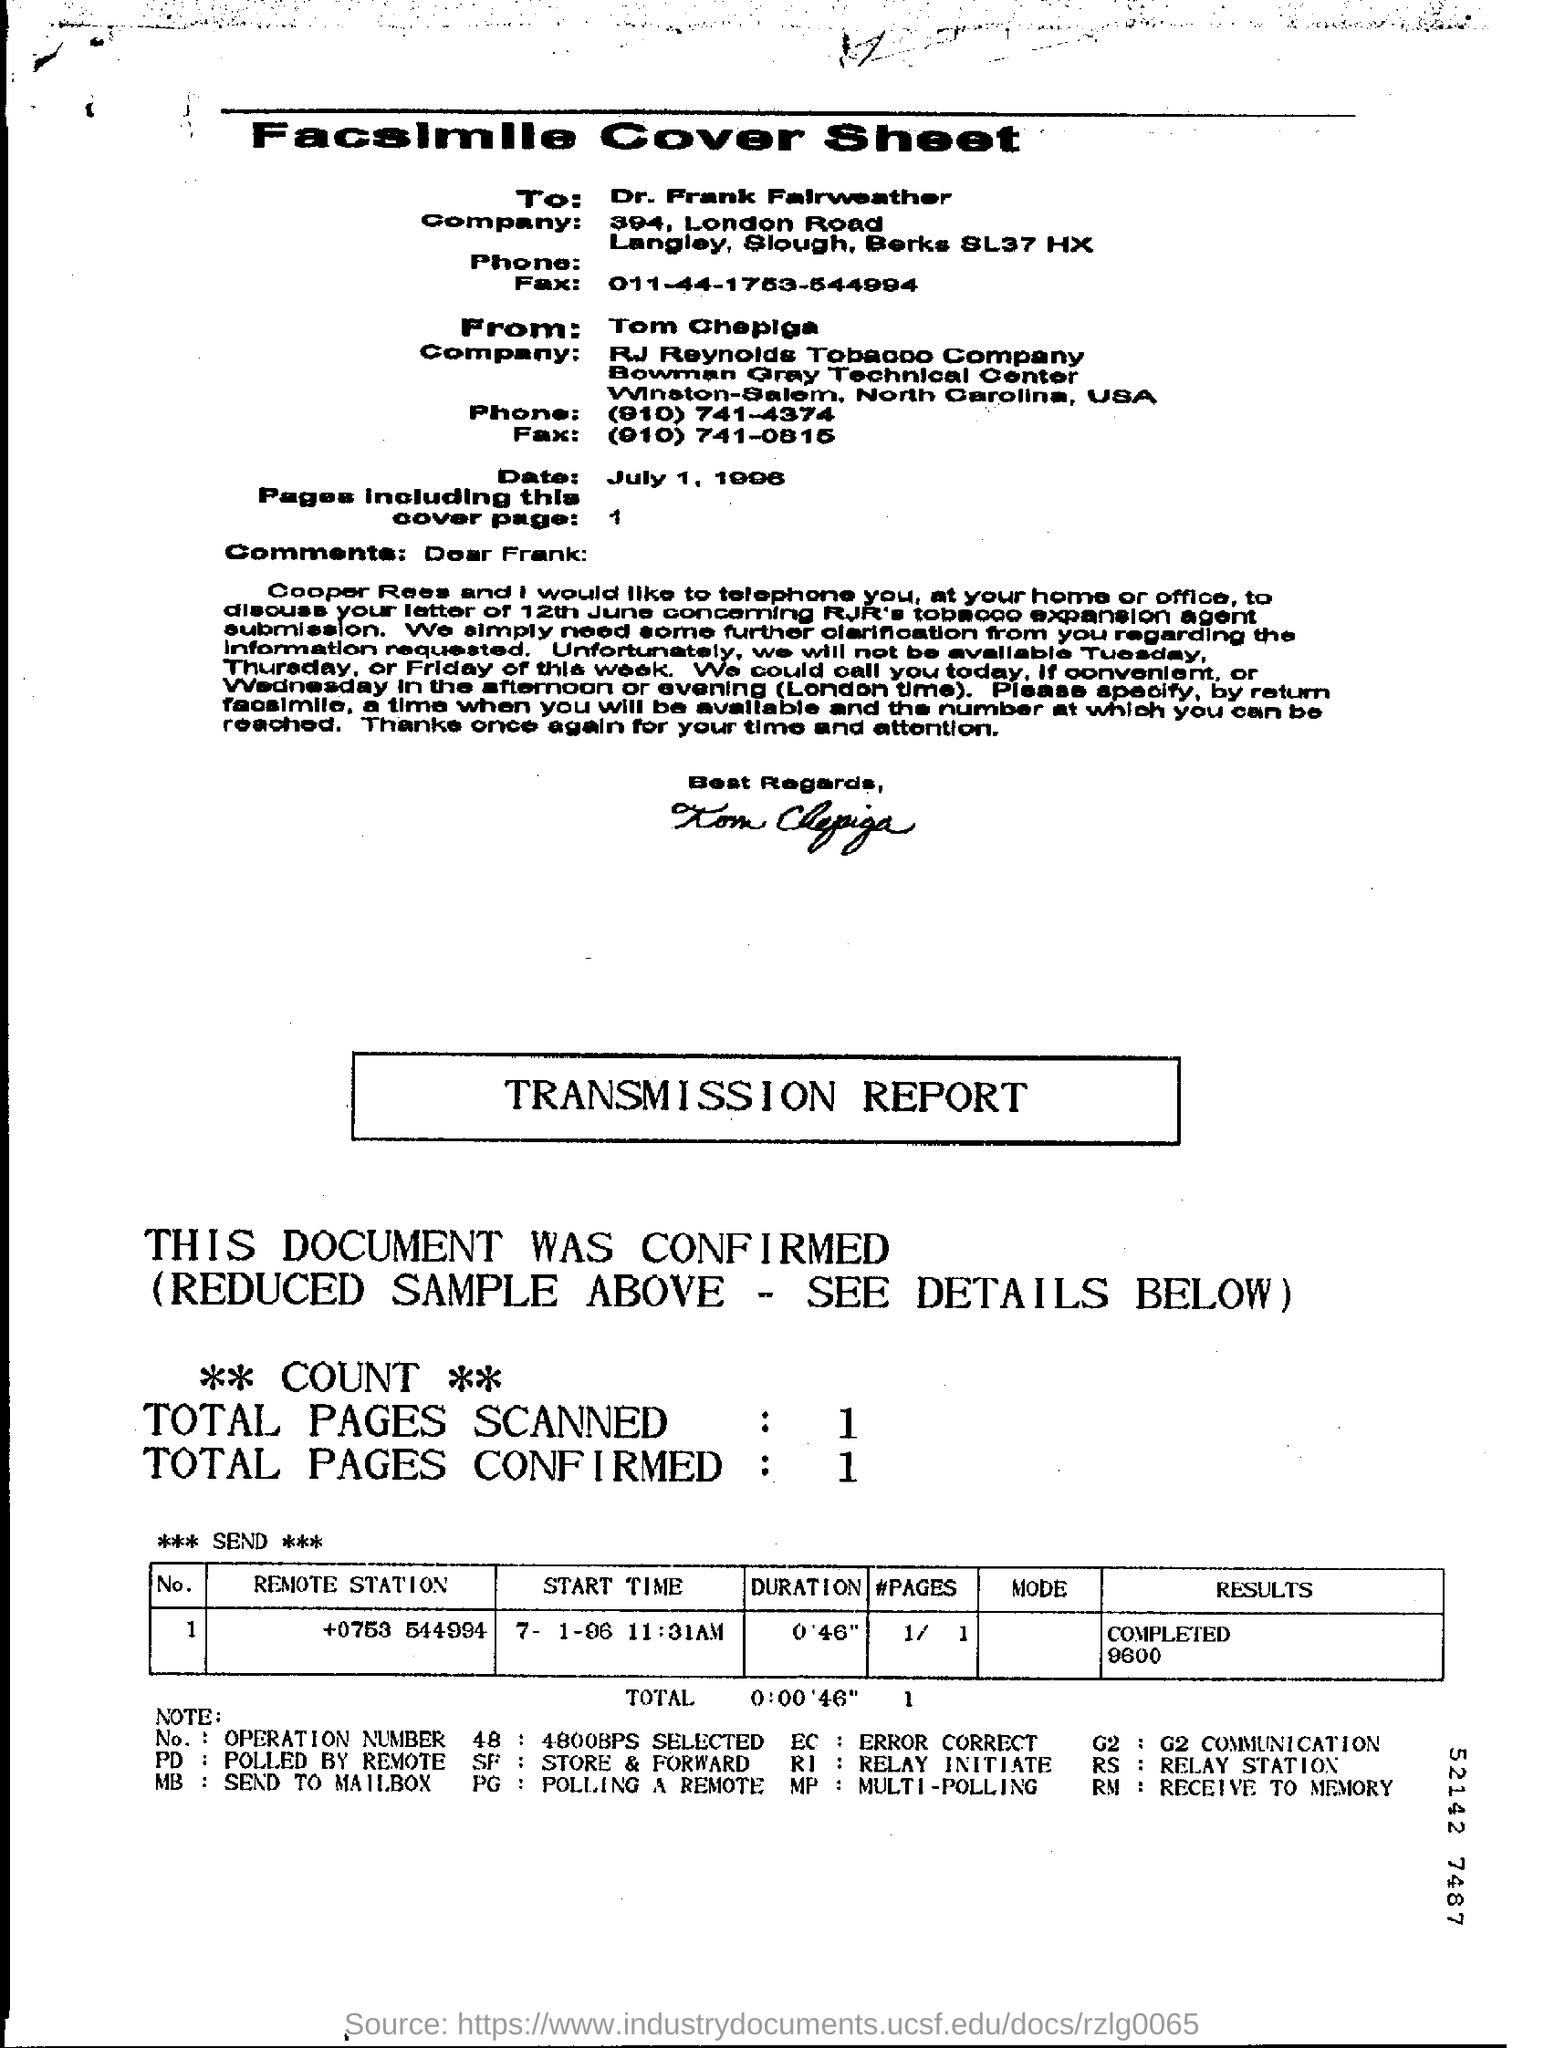Specify some key components in this picture. The facsimile cover sheet has been written by Tom Chepiga. The date mentioned in the cover sheet is July 1, 1996. According to the transmission report, a total of 1 page has been confirmed. The person whose name is listed in the "To" field on the cover sheet is Dr. Frank Fairweather. The duration mentioned in the transmission report is 0'46". 